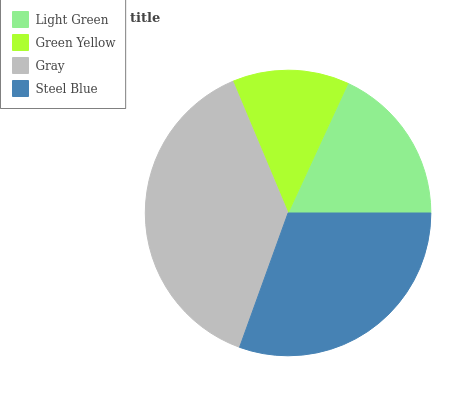Is Green Yellow the minimum?
Answer yes or no. Yes. Is Gray the maximum?
Answer yes or no. Yes. Is Gray the minimum?
Answer yes or no. No. Is Green Yellow the maximum?
Answer yes or no. No. Is Gray greater than Green Yellow?
Answer yes or no. Yes. Is Green Yellow less than Gray?
Answer yes or no. Yes. Is Green Yellow greater than Gray?
Answer yes or no. No. Is Gray less than Green Yellow?
Answer yes or no. No. Is Steel Blue the high median?
Answer yes or no. Yes. Is Light Green the low median?
Answer yes or no. Yes. Is Gray the high median?
Answer yes or no. No. Is Gray the low median?
Answer yes or no. No. 